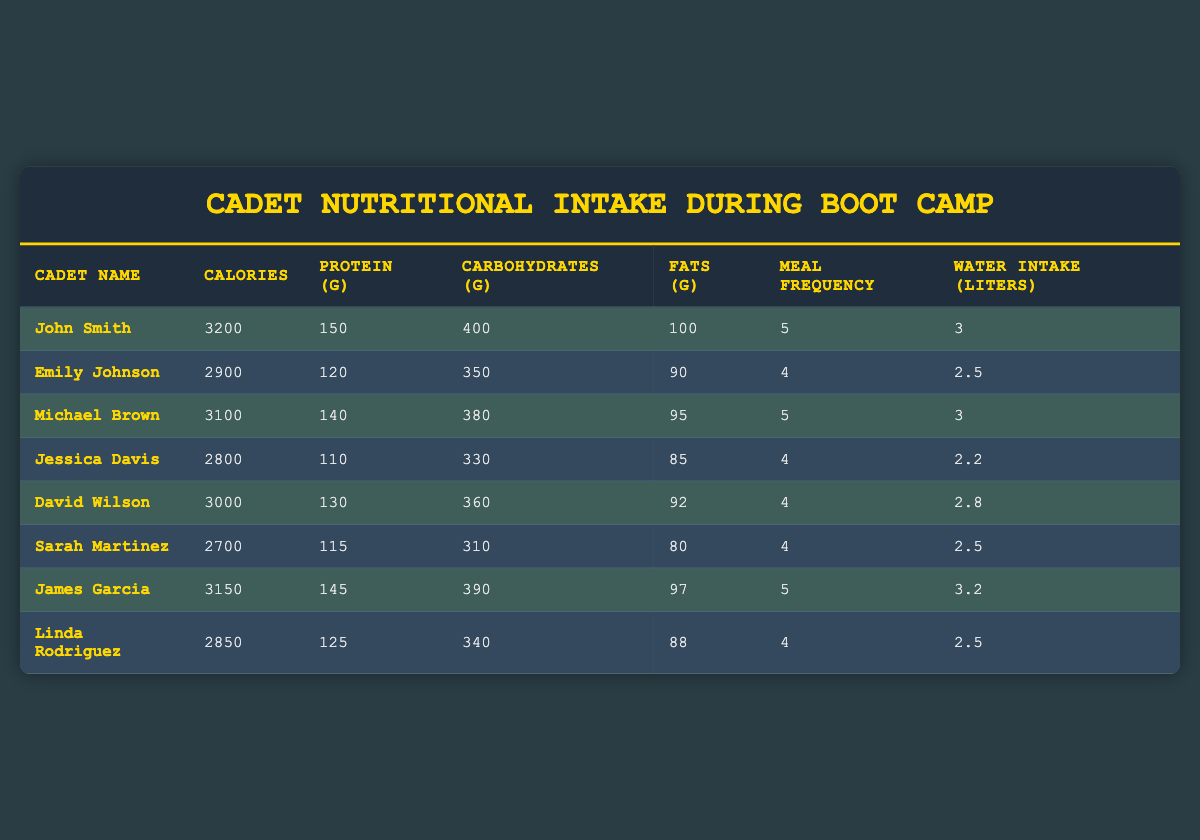What is the calorie intake of John Smith? John Smith's calorie intake is listed directly in the table under 'Calories', which shows 3200 calories.
Answer: 3200 Who has the highest protein intake? By comparing the values in the 'Protein (g)' column, John Smith has the highest intake at 150 grams.
Answer: John Smith What is the average meal frequency of all cadets? The sum of the meal frequencies is (5 + 4 + 5 + 4 + 4 + 4 + 5 + 4) = 35. There are 8 cadets, so the average is 35/8 = 4.375, which can be rounded to 4.4.
Answer: 4.4 Is Jessica Davis's fat intake greater than Emily Johnson's? Jessica Davis’s fat intake is 85 grams and Emily Johnson’s is 90 grams. Since 85 is less than 90, the statement is false.
Answer: No What is the total water intake of all cadets? The total water intake is found by adding the liters of water for each cadet: 3 + 2.5 + 3 + 2.2 + 2.8 + 2.5 + 3.2 + 2.5 = 22.7 liters.
Answer: 22.7 Which cadet has the lowest carbohydrate intake? By looking at the 'Carbohydrates (g)' column, Sarah Martinez has the lowest intake at 310 grams.
Answer: Sarah Martinez If we take the cadets who consume more than 3000 calories, how many are there? The only cadets with more than 3000 calories are John Smith (3200) and James Garcia (3150). Thus, there are 2 cadets.
Answer: 2 What is the difference in calorie intake between David Wilson and Sarah Martinez? David Wilson consumes 3000 calories, while Sarah Martinez consumes 2700 calories. The difference is 3000 - 2700 = 300 calories.
Answer: 300 How many cadets have a protein intake of at least 130 grams? The cadets with at least 130 grams of protein are John Smith (150), Michael Brown (140), and James Garcia (145). This counts to 3 cadets.
Answer: 3 Which cadet has the most balanced macronutrient intake based on equal proportions of calories from protein, carbohydrates, and fats? To find the most balanced cadet, we would need to compare the proportions. John Smith: Protein = 150g (600 kcal), Carbs = 400g (1600 kcal), Fats = 100g (900 kcal). This suggests John Smith has the most balanced macronutrient intake considering proportions.
Answer: John Smith 